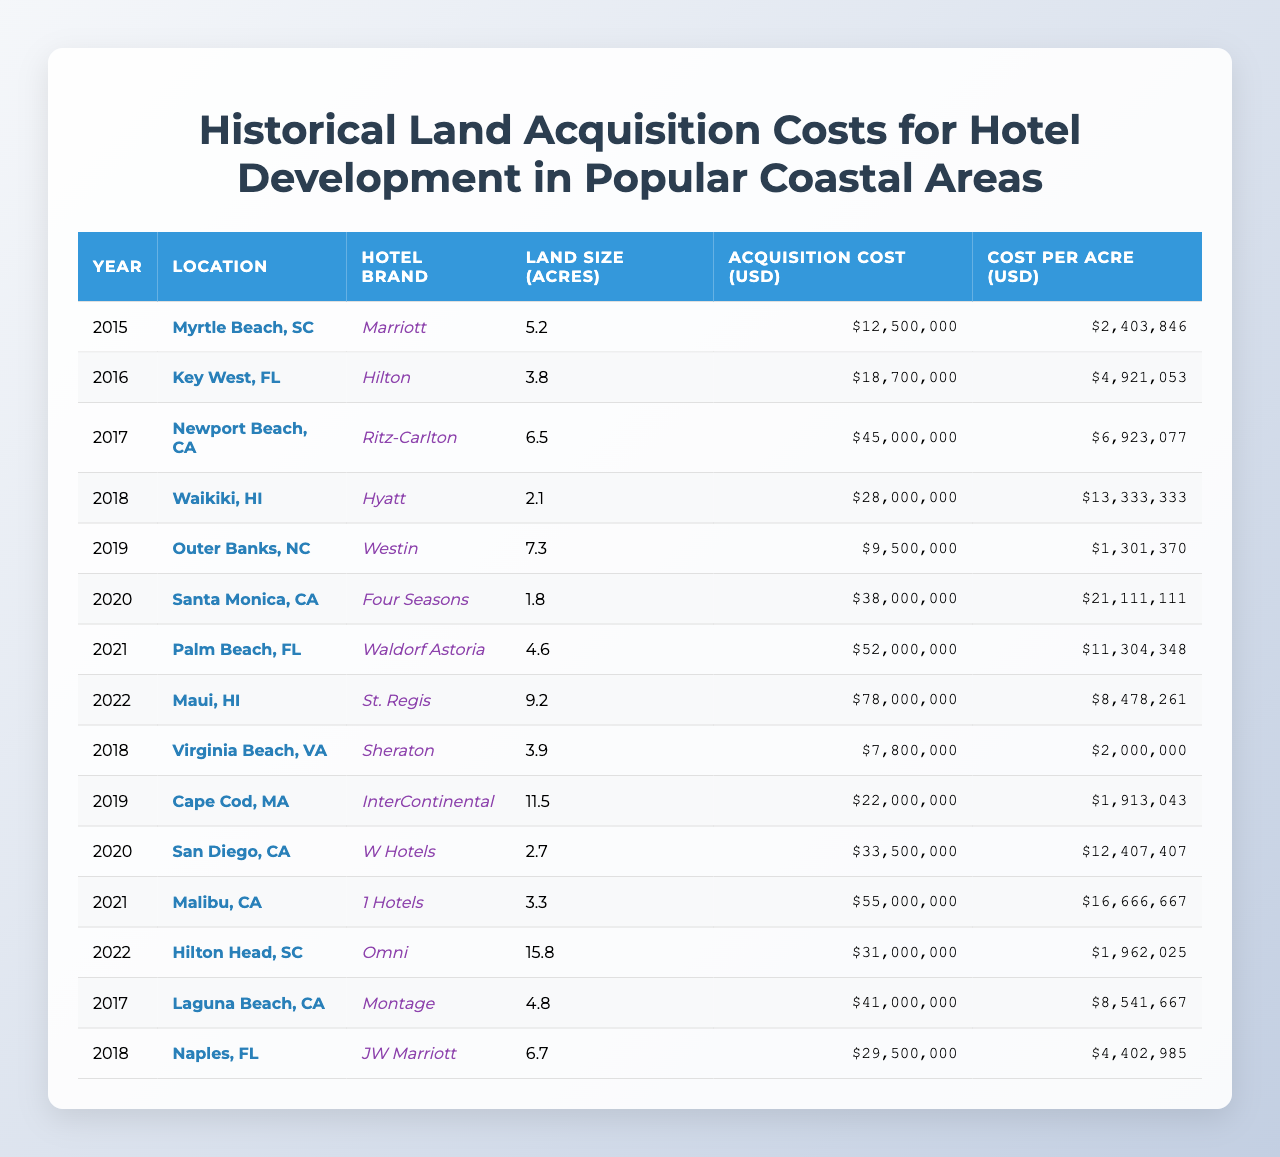What was the acquisition cost for the Marriott hotel in Myrtle Beach, SC in 2015? The table states that the acquisition cost for the Marriott hotel located in Myrtle Beach, SC in the year 2015 was 12,500,000 USD.
Answer: 12,500,000 USD What is the cost per acre for the Hilton hotel in Key West, FL in 2016? According to the table, the cost per acre for the Hilton hotel in Key West, FL in 2016 was 4,921,053 USD.
Answer: 4,921,053 USD Which hotel had the highest acquisition cost and what was that cost? By examining the table, the St. Regis hotel in Maui, HI had the highest acquisition cost at 78,000,000 USD.
Answer: 78,000,000 USD How many acres of land were acquired for the Westin hotel in Outer Banks, NC in 2019? The table shows that the land size acquired for the Westin hotel in Outer Banks, NC in 2019 was 7.3 acres.
Answer: 7.3 acres What is the average acquisition cost for the hotels in California from the table? The acquisition costs for hotels in California are 45,000,000 (Ritz-Carlton), 38,000,000 (Four Seasons), 55,000,000 (1 Hotels), and 41,000,000 (Montage). Adding these gives 179,000,000 USD, and dividing by 4 gives an average of 44,750,000 USD.
Answer: 44,750,000 USD Which hotel brand had the lowest cost per acre? From the table, the Westin hotel in Outer Banks, NC had the lowest cost per acre at 1,301,370 USD, which is the minimum value when analyzed.
Answer: 1,301,370 USD Did the acquisition cost for the hotel in Waikiki, HI exceed 25 million USD? Looking at the table, the acquisition cost for the Hyatt hotel in Waikiki, HI was 28,000,000 USD, which indeed exceeds 25 million USD.
Answer: Yes How much did the cost per acre increase from the Hyatt in Waikiki, HI (2018) to the Waldorf Astoria in Palm Beach, FL (2021)? The cost per acre for Hyatt in Waikiki in 2018 was 13,333,333 USD and for Waldorf Astoria in Palm Beach in 2021 was 11,304,348 USD. The increase is not applicable since it actually decreased, which is calculated as 11,304,348 - 13,333,333 = -2,028,985.
Answer: Decreased by 2,028,985 USD Which location had the largest land size and what was the size? The table indicates that Hilton Head, SC had the largest land size at 15.8 acres for the Omni hotel.
Answer: 15.8 acres What is the difference in acquisition cost between the Ritz-Carlton hotel in Newport Beach, CA and the Four Seasons hotel in Santa Monica, CA? The acquisition cost for Ritz-Carlton in Newport Beach is 45,000,000 USD and for Four Seasons in Santa Monica is 38,000,000 USD. The difference is calculated as 45,000,000 - 38,000,000 = 7,000,000.
Answer: 7,000,000 USD 